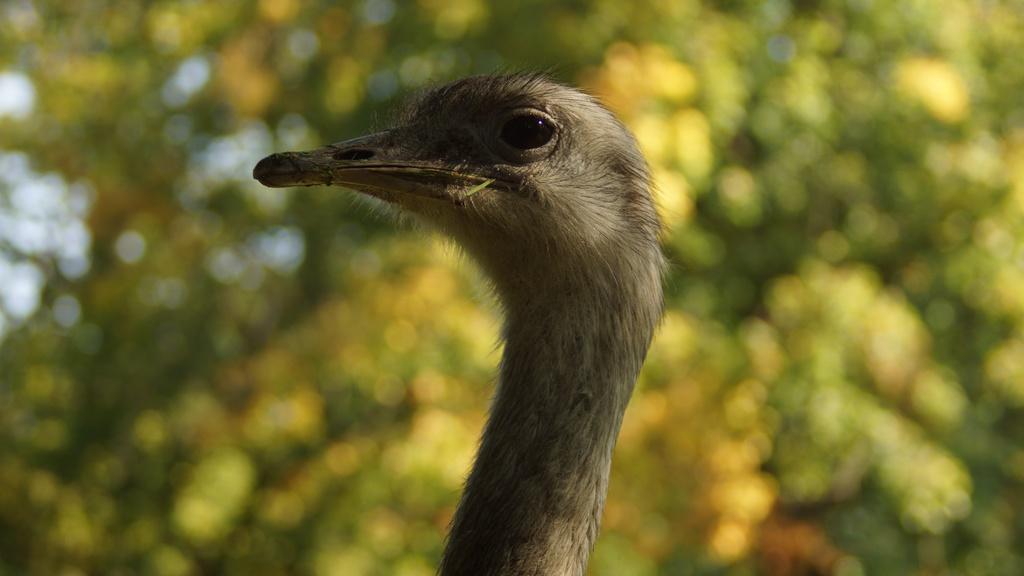Describe this image in one or two sentences. In this picture there is a bird which is in cream color. At the back there are trees. At the top there is sky. 